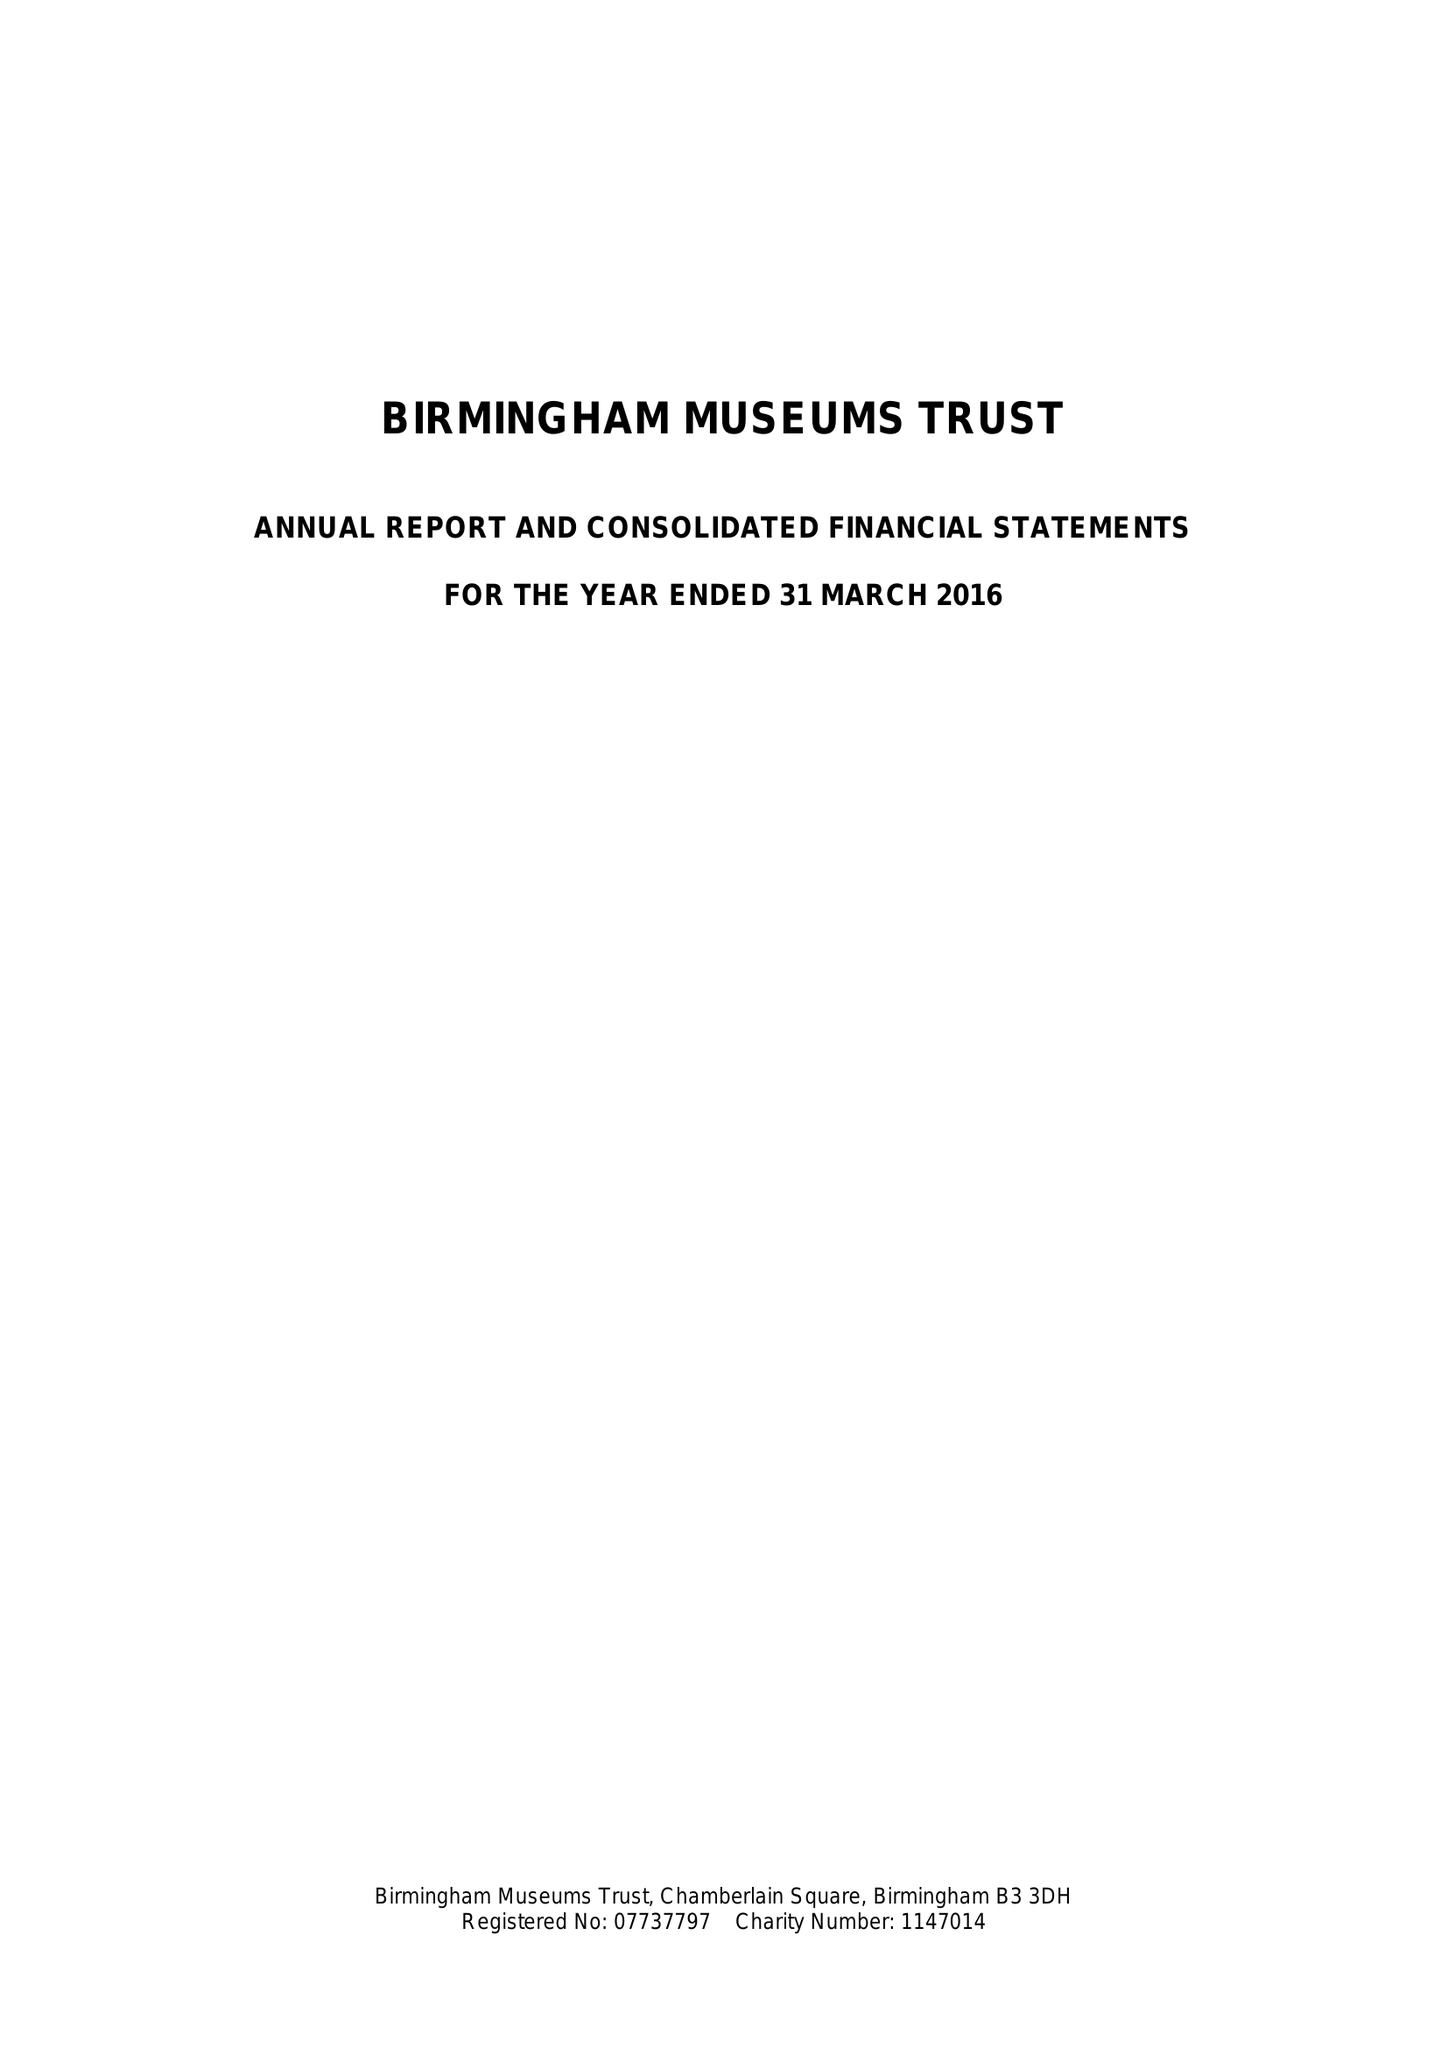What is the value for the income_annually_in_british_pounds?
Answer the question using a single word or phrase. 12875000.00 